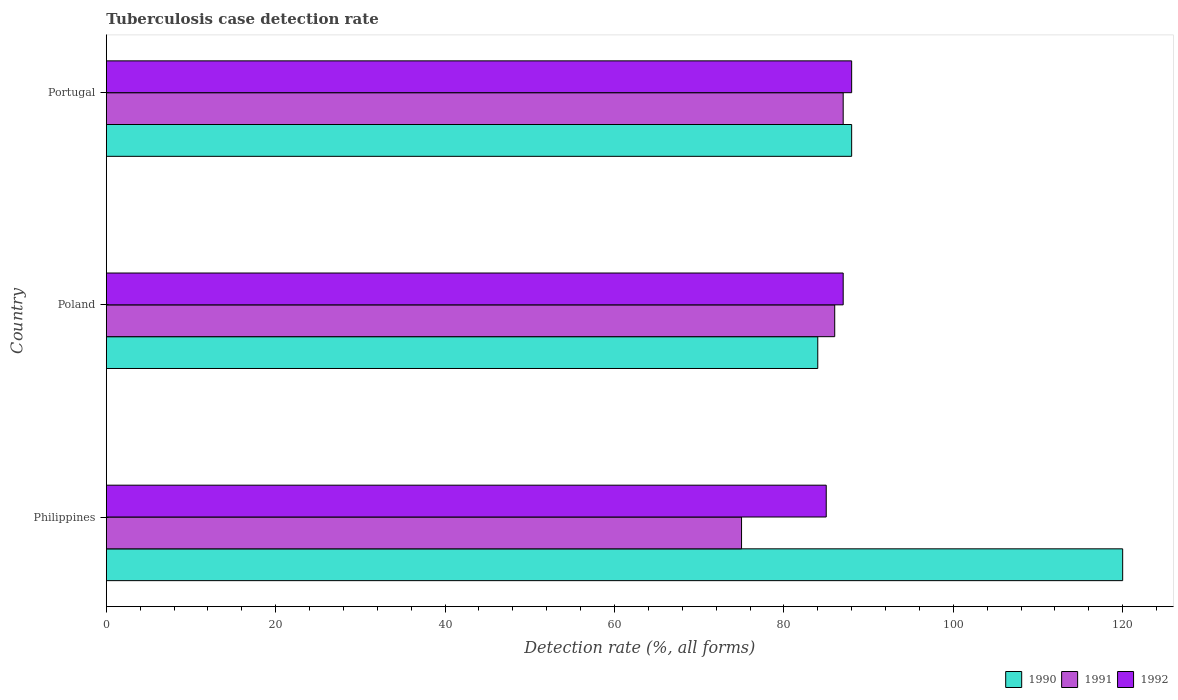Are the number of bars per tick equal to the number of legend labels?
Your response must be concise. Yes. How many bars are there on the 3rd tick from the top?
Ensure brevity in your answer.  3. What is the label of the 3rd group of bars from the top?
Ensure brevity in your answer.  Philippines. What is the tuberculosis case detection rate in in 1992 in Poland?
Offer a terse response. 87. Across all countries, what is the maximum tuberculosis case detection rate in in 1992?
Give a very brief answer. 88. Across all countries, what is the minimum tuberculosis case detection rate in in 1992?
Offer a very short reply. 85. What is the total tuberculosis case detection rate in in 1992 in the graph?
Offer a very short reply. 260. What is the average tuberculosis case detection rate in in 1990 per country?
Give a very brief answer. 97.33. What is the difference between the tuberculosis case detection rate in in 1991 and tuberculosis case detection rate in in 1990 in Philippines?
Provide a succinct answer. -45. In how many countries, is the tuberculosis case detection rate in in 1990 greater than 64 %?
Offer a very short reply. 3. What is the ratio of the tuberculosis case detection rate in in 1990 in Philippines to that in Poland?
Give a very brief answer. 1.43. Is the tuberculosis case detection rate in in 1992 in Poland less than that in Portugal?
Offer a terse response. Yes. Is the difference between the tuberculosis case detection rate in in 1991 in Philippines and Portugal greater than the difference between the tuberculosis case detection rate in in 1990 in Philippines and Portugal?
Your answer should be very brief. No. What is the difference between the highest and the lowest tuberculosis case detection rate in in 1990?
Ensure brevity in your answer.  36. Is the sum of the tuberculosis case detection rate in in 1992 in Philippines and Portugal greater than the maximum tuberculosis case detection rate in in 1991 across all countries?
Give a very brief answer. Yes. What does the 1st bar from the bottom in Philippines represents?
Your answer should be compact. 1990. Is it the case that in every country, the sum of the tuberculosis case detection rate in in 1990 and tuberculosis case detection rate in in 1991 is greater than the tuberculosis case detection rate in in 1992?
Ensure brevity in your answer.  Yes. Are all the bars in the graph horizontal?
Your answer should be compact. Yes. Are the values on the major ticks of X-axis written in scientific E-notation?
Your answer should be very brief. No. How many legend labels are there?
Provide a short and direct response. 3. What is the title of the graph?
Your answer should be compact. Tuberculosis case detection rate. What is the label or title of the X-axis?
Your answer should be very brief. Detection rate (%, all forms). What is the label or title of the Y-axis?
Provide a succinct answer. Country. What is the Detection rate (%, all forms) of 1990 in Philippines?
Make the answer very short. 120. What is the Detection rate (%, all forms) in 1991 in Philippines?
Offer a very short reply. 75. What is the Detection rate (%, all forms) in 1992 in Philippines?
Give a very brief answer. 85. What is the Detection rate (%, all forms) in 1990 in Poland?
Provide a short and direct response. 84. What is the Detection rate (%, all forms) in 1991 in Poland?
Offer a very short reply. 86. What is the Detection rate (%, all forms) of 1992 in Poland?
Offer a terse response. 87. What is the Detection rate (%, all forms) of 1990 in Portugal?
Ensure brevity in your answer.  88. What is the Detection rate (%, all forms) of 1991 in Portugal?
Offer a very short reply. 87. Across all countries, what is the maximum Detection rate (%, all forms) in 1990?
Your answer should be very brief. 120. Across all countries, what is the maximum Detection rate (%, all forms) of 1992?
Ensure brevity in your answer.  88. Across all countries, what is the minimum Detection rate (%, all forms) of 1990?
Ensure brevity in your answer.  84. What is the total Detection rate (%, all forms) of 1990 in the graph?
Make the answer very short. 292. What is the total Detection rate (%, all forms) in 1991 in the graph?
Provide a succinct answer. 248. What is the total Detection rate (%, all forms) in 1992 in the graph?
Provide a succinct answer. 260. What is the difference between the Detection rate (%, all forms) in 1990 in Philippines and that in Poland?
Your answer should be compact. 36. What is the difference between the Detection rate (%, all forms) of 1991 in Philippines and that in Poland?
Make the answer very short. -11. What is the difference between the Detection rate (%, all forms) of 1990 in Philippines and that in Portugal?
Give a very brief answer. 32. What is the difference between the Detection rate (%, all forms) of 1992 in Philippines and that in Portugal?
Provide a short and direct response. -3. What is the difference between the Detection rate (%, all forms) of 1991 in Poland and that in Portugal?
Keep it short and to the point. -1. What is the difference between the Detection rate (%, all forms) in 1992 in Poland and that in Portugal?
Offer a terse response. -1. What is the difference between the Detection rate (%, all forms) of 1990 in Philippines and the Detection rate (%, all forms) of 1991 in Poland?
Provide a short and direct response. 34. What is the difference between the Detection rate (%, all forms) of 1991 in Philippines and the Detection rate (%, all forms) of 1992 in Poland?
Offer a very short reply. -12. What is the difference between the Detection rate (%, all forms) of 1990 in Poland and the Detection rate (%, all forms) of 1991 in Portugal?
Your answer should be compact. -3. What is the difference between the Detection rate (%, all forms) in 1990 in Poland and the Detection rate (%, all forms) in 1992 in Portugal?
Your answer should be compact. -4. What is the difference between the Detection rate (%, all forms) in 1991 in Poland and the Detection rate (%, all forms) in 1992 in Portugal?
Your answer should be compact. -2. What is the average Detection rate (%, all forms) in 1990 per country?
Offer a very short reply. 97.33. What is the average Detection rate (%, all forms) of 1991 per country?
Provide a succinct answer. 82.67. What is the average Detection rate (%, all forms) of 1992 per country?
Offer a very short reply. 86.67. What is the difference between the Detection rate (%, all forms) in 1990 and Detection rate (%, all forms) in 1992 in Philippines?
Your answer should be compact. 35. What is the difference between the Detection rate (%, all forms) of 1990 and Detection rate (%, all forms) of 1991 in Poland?
Your answer should be compact. -2. What is the difference between the Detection rate (%, all forms) of 1991 and Detection rate (%, all forms) of 1992 in Portugal?
Keep it short and to the point. -1. What is the ratio of the Detection rate (%, all forms) in 1990 in Philippines to that in Poland?
Offer a very short reply. 1.43. What is the ratio of the Detection rate (%, all forms) in 1991 in Philippines to that in Poland?
Ensure brevity in your answer.  0.87. What is the ratio of the Detection rate (%, all forms) in 1992 in Philippines to that in Poland?
Provide a short and direct response. 0.98. What is the ratio of the Detection rate (%, all forms) in 1990 in Philippines to that in Portugal?
Give a very brief answer. 1.36. What is the ratio of the Detection rate (%, all forms) of 1991 in Philippines to that in Portugal?
Your answer should be very brief. 0.86. What is the ratio of the Detection rate (%, all forms) in 1992 in Philippines to that in Portugal?
Ensure brevity in your answer.  0.97. What is the ratio of the Detection rate (%, all forms) in 1990 in Poland to that in Portugal?
Your response must be concise. 0.95. What is the ratio of the Detection rate (%, all forms) in 1991 in Poland to that in Portugal?
Keep it short and to the point. 0.99. What is the difference between the highest and the second highest Detection rate (%, all forms) in 1991?
Your answer should be very brief. 1. What is the difference between the highest and the lowest Detection rate (%, all forms) of 1990?
Offer a very short reply. 36. 